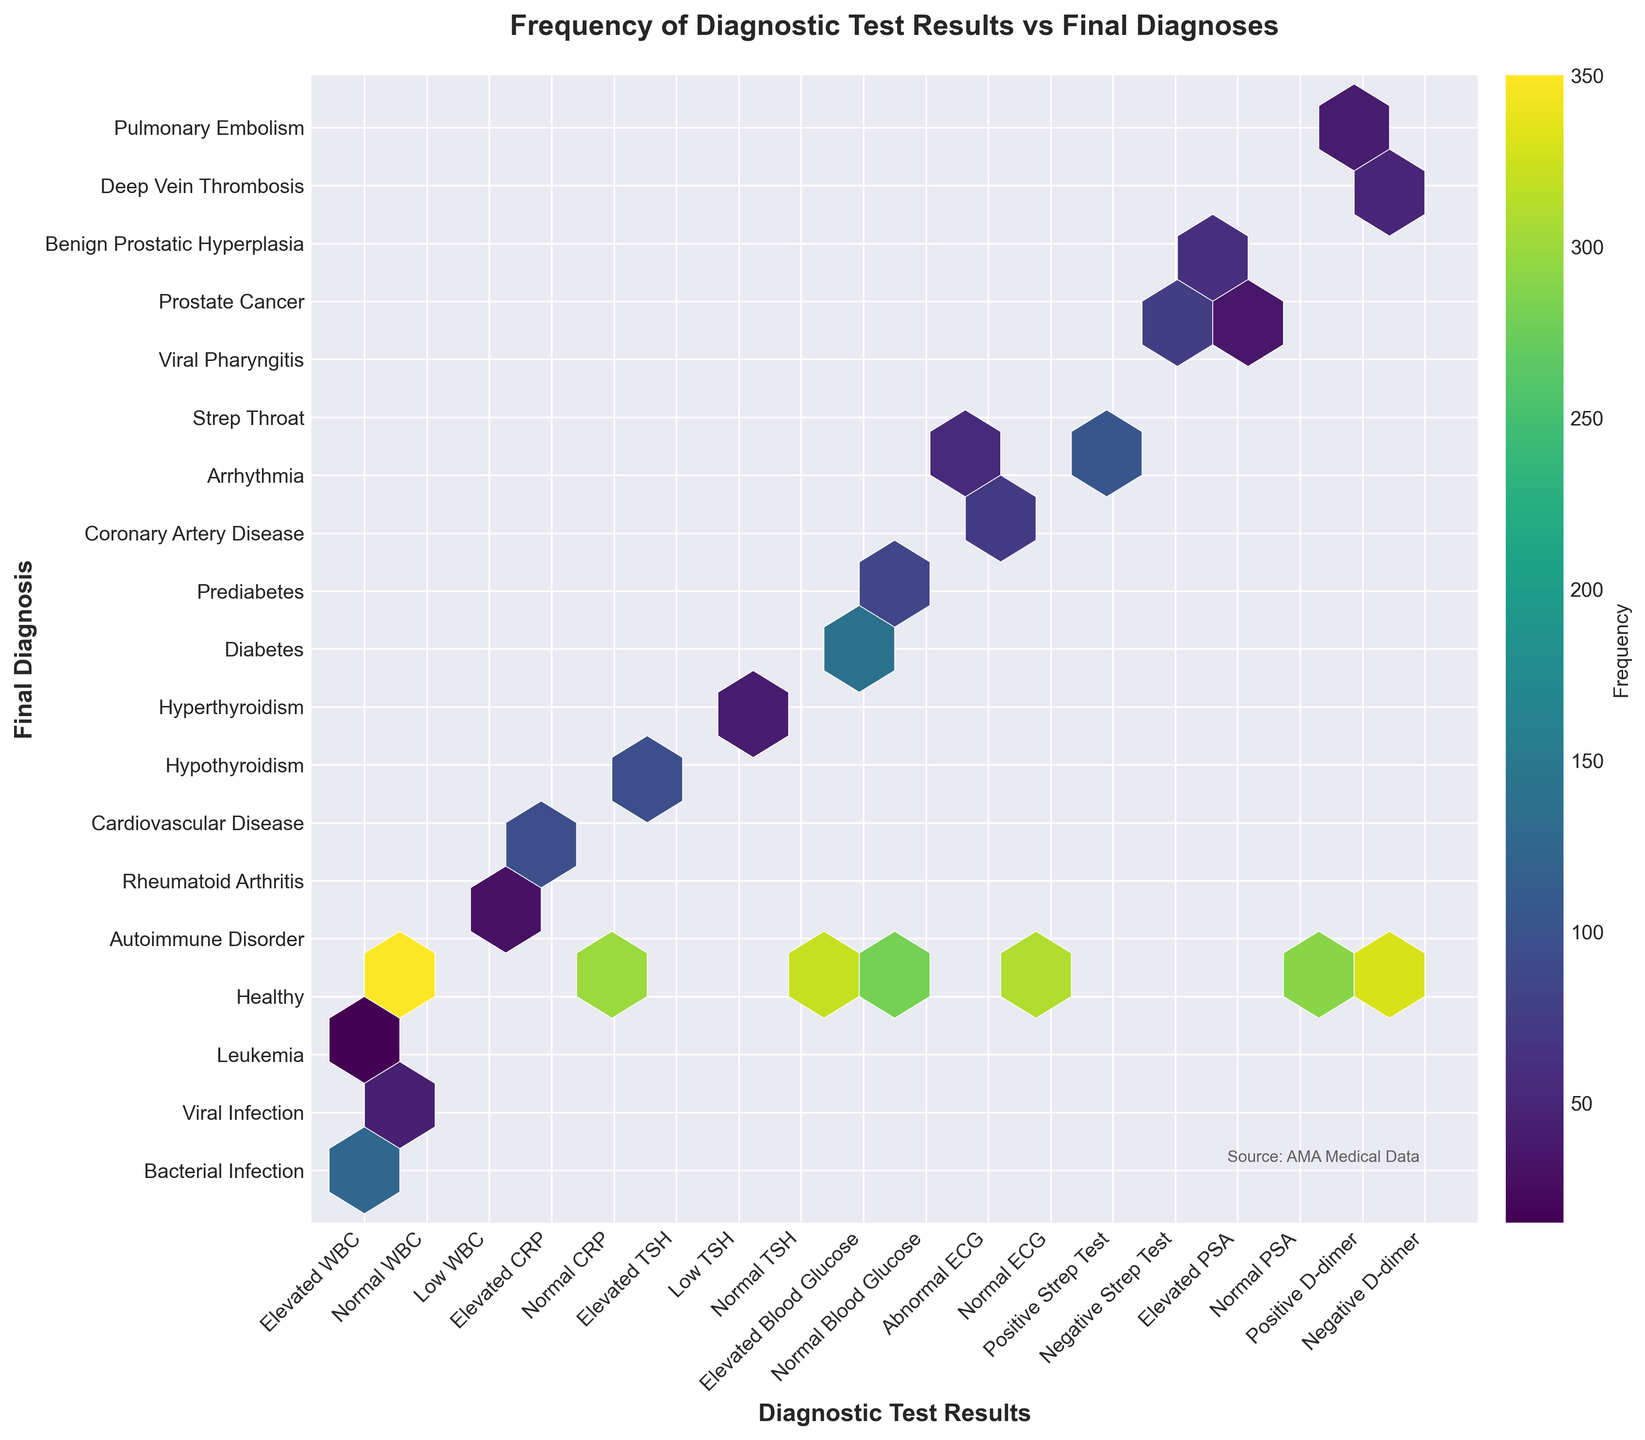What is the title of the hexbin plot? The title of the hexbin plot is typically located at the top center of the figure. By reading this title, we can directly identify what the plot is about without needing to interpret the content first.
Answer: Frequency of Diagnostic Test Results vs Final Diagnoses Which diagnostic test result is most frequently associated with a healthy diagnosis? To answer this, locate the "Healthy" label on the y-axis and find the hexbin with the highest color intensity in that row. Check the x-axis label for this hexbin.
Answer: Normal WBC What diagnostic test result is associated with Strep Throat, and how often does it occur? Find the row labeled "Strep Throat" on the y-axis and look at the hexbin's position in this row. Then find the x-axis label for that hexbin and refer to the color intensity to determine the frequency.
Answer: Positive Strep Test, 105 Comparing Bacterial Infection and Viral Infection, which diagnostic test result has a higher frequency for each? Check the rows corresponding to "Bacterial Infection" and "Viral Infection" on the y-axis. Compare the test results against each other by looking at the color intensity for "Elevated WBC" hexbin in both rows.
Answer: Elevated WBC has a higher frequency in Bacterial Infection than Viral Infection What are the three most common final diagnoses based on the hexbin plot? Identify the three most intense hexbins on the plot, and then check the y-axis labels for these hexbins to determine the final diagnoses.
Answer: Healthy, Prediabetes, Diabetes How does the frequency of Elevated CRP in Cardiovascular Disease compare to Rheumatoid Arthritis? Locate the row for "Cardiovascular Disease" on the y-axis and find the hexbin for "Elevated CRP." Then do the same for "Rheumatoid Arthritis" and compare the color intensities.
Answer: The frequency is higher for Cardiovascular Disease Which test result-diagnosis combination has the least frequency? Look for the hexbin with the lowest color intensity across the entire plot and check both x and y-axis labels for that hexbin.
Answer: Elevated WBC, Leukemia What diagnostic test results lead to diagnoses related to thyroid conditions? Find the rows labeled "Hypothyroidism" and "Hyperthyroidism" on the y-axis. Follow the diagonals through these rows to identify the associated test results on the x-axis.
Answer: Elevated TSH for Hypothyroidism and Low TSH for Hyperthyroidism What is the frequency difference between Diabetes and Prediabetes for Elevated Blood Glucose? Locate the hexbins for "Elevated Blood Glucose" in the rows for "Diabetes" and "Prediabetes" on the y-axis. Subtract the frequency values represented by the color intensities of these hexbins.
Answer: 140 (Diabetes) - 85 (Prediabetes) = 55 How does Normal ECG's frequency compare to Abnormal ECG's frequency for any diagnoses? Compare the color intensities of the rows containing Normal ECG and Abnormal ECG across the plot.
Answer: Normal ECG tends to have a higher frequency for any diagnoses, particularly for Healthy 